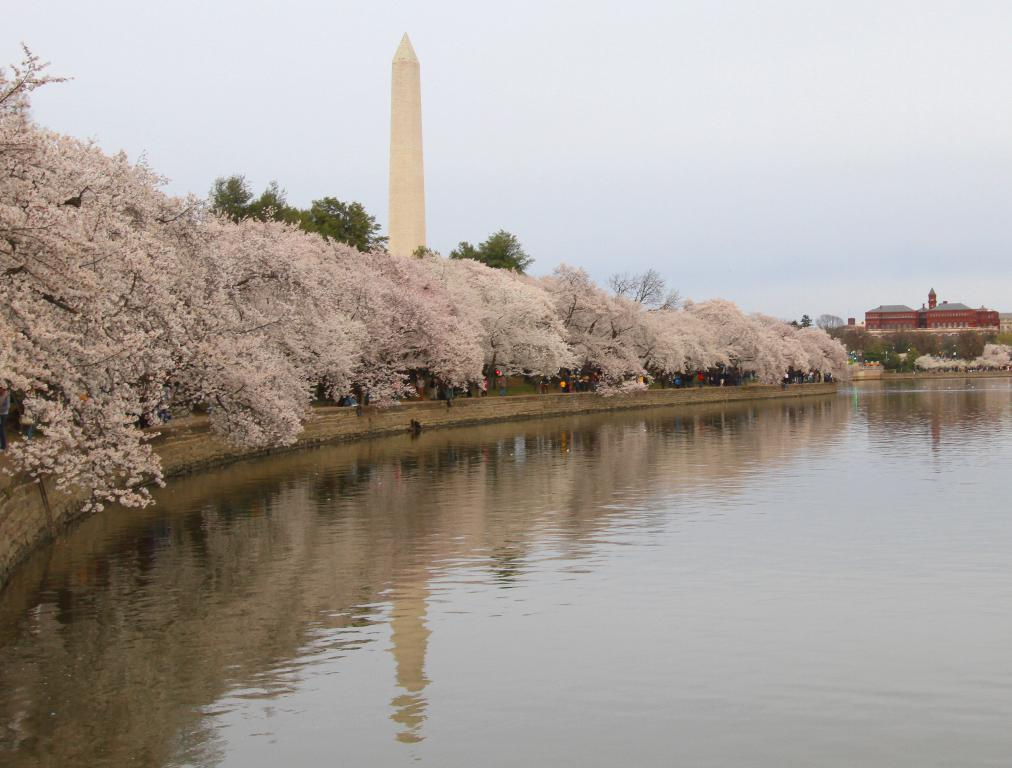What is the primary element visible in the image? There is water in the image. What type of vegetation can be seen on the left side of the image? There are trees on the ground to the left. What structures are visible in the background of the image? There are buildings in the background. What is visible at the top of the image? The sky is visible at the top of the image. What stands out in the center of the image? There is a tower in the center of the image. Can you tell me how many friends are depicted in jail in the image? There is no reference to friends or jail in the image; it features water, trees, buildings, the sky, and a tower. 